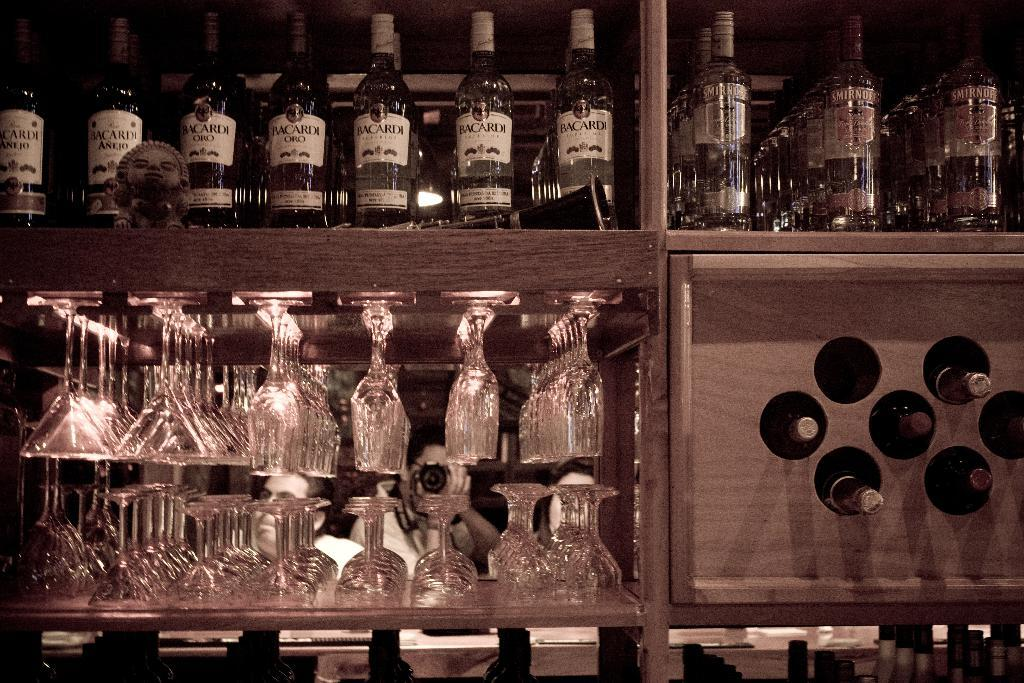What is present on the shelf in the image? There are glasses and bottles on the shelf in the image. Can you describe the glasses on the shelf? The glasses on the shelf are visible in the image. What else is present on the shelf besides the glasses? There are bottles on the shelf in the image. What type of lamp is present on the shelf in the image? There is no lamp present on the shelf in the image. What is the belief system of the glasses on the shelf? The glasses on the shelf do not have a belief system, as they are inanimate objects. 